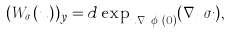<formula> <loc_0><loc_0><loc_500><loc_500>( W _ { \sigma _ { i } } ( u ) ) _ { y } = d \exp _ { u \nabla _ { x } \phi _ { i } ( 0 ) } ( \nabla _ { x } \sigma _ { i } ) ,</formula> 